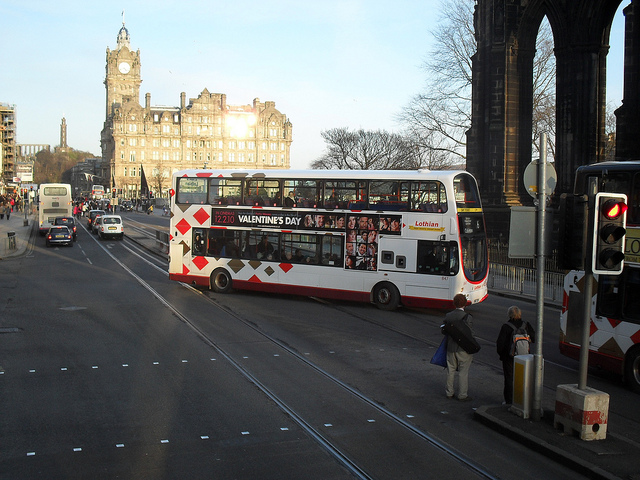Identify and read out the text in this image. VALENTINE'S DAY 